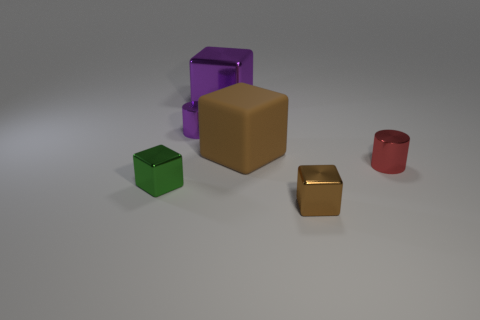What number of brown shiny things are the same size as the red cylinder?
Your response must be concise. 1. What number of metal things are right of the brown thing that is in front of the small green object?
Your answer should be very brief. 1. What size is the cube that is both in front of the tiny red object and right of the green object?
Keep it short and to the point. Small. Is the number of small shiny cylinders greater than the number of small red metal things?
Provide a succinct answer. Yes. Is there a small metal thing that has the same color as the rubber block?
Keep it short and to the point. Yes. Is the size of the green shiny object in front of the red object the same as the tiny red metal cylinder?
Provide a short and direct response. Yes. Are there fewer small cylinders than small red metallic objects?
Provide a short and direct response. No. Is there a small purple object made of the same material as the small red object?
Your answer should be very brief. Yes. There is a small metal object left of the purple metallic cylinder; what is its shape?
Keep it short and to the point. Cube. Does the tiny metal cylinder on the left side of the red metallic thing have the same color as the big metallic thing?
Your answer should be very brief. Yes. 